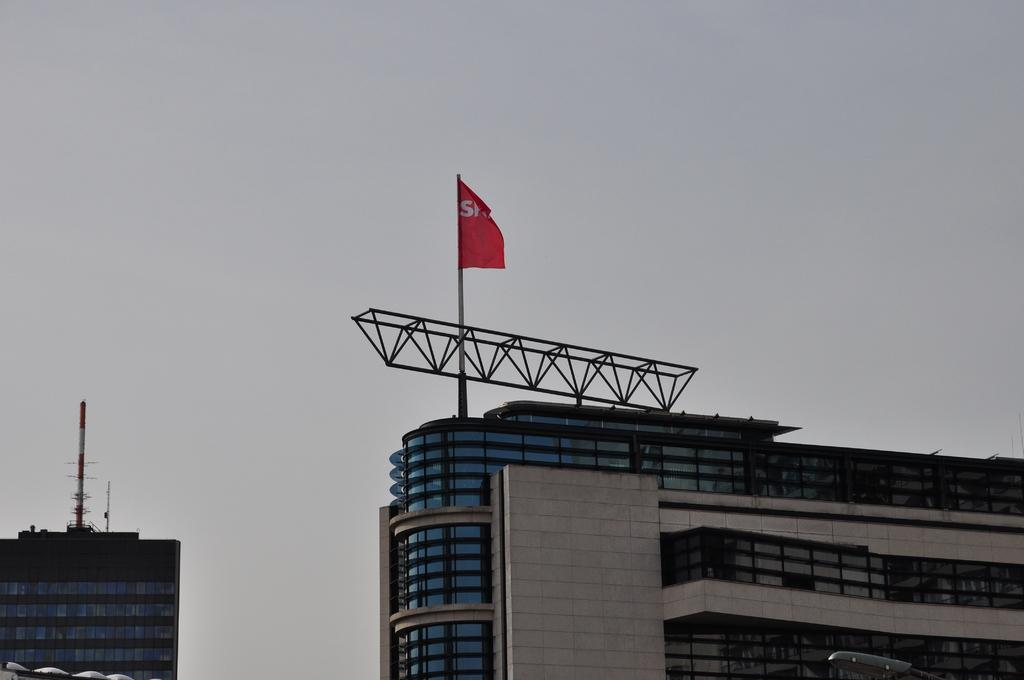What is the main structure in the image? There is a huge building in the image. What is attached to the top of the building? There is a flag flying in the air on top of the building. What can be seen opposite to the building? There is another tower opposite to the building. What is visible in the background of the image? The sky is visible in the background of the image. What type of holiday is being celebrated in the image? There is no indication of a holiday being celebrated in the image. What does the building regret in the image? Buildings do not have the ability to feel regret, so this question is not applicable to the image. 